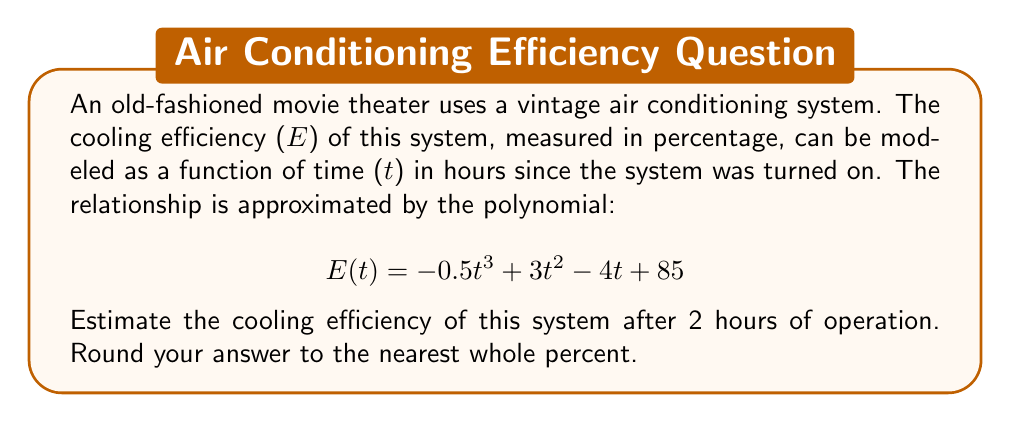Help me with this question. To solve this problem, we need to follow these steps:

1) We are given the polynomial function for the cooling efficiency:
   $$ E(t) = -0.5t^3 + 3t^2 - 4t + 85 $$

2) We need to find E(2), as we want to know the efficiency after 2 hours:
   $$ E(2) = -0.5(2)^3 + 3(2)^2 - 4(2) + 85 $$

3) Let's calculate each term:
   - $-0.5(2)^3 = -0.5(8) = -4$
   - $3(2)^2 = 3(4) = 12$
   - $-4(2) = -8$
   - The constant term is 85

4) Now, let's sum these terms:
   $$ E(2) = -4 + 12 - 8 + 85 = 85 $$

5) The question asks for the answer rounded to the nearest whole percent, but 85 is already a whole number.

Therefore, the cooling efficiency after 2 hours is estimated to be 85%.
Answer: 85% 